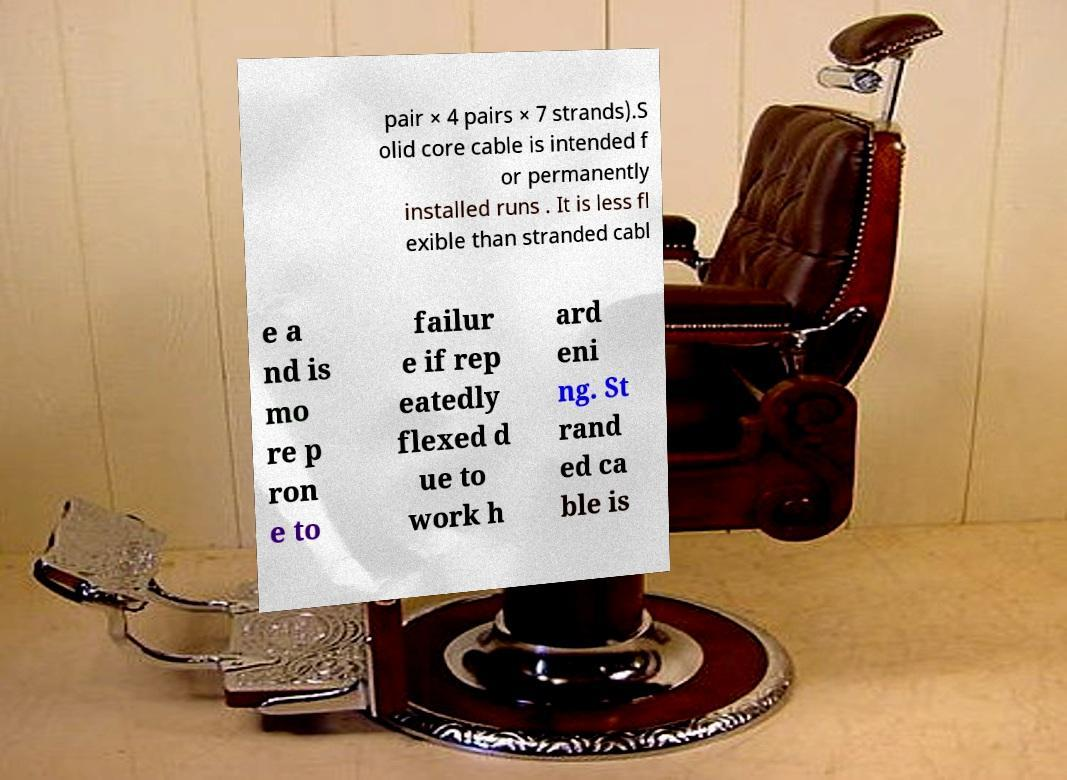What messages or text are displayed in this image? I need them in a readable, typed format. pair × 4 pairs × 7 strands).S olid core cable is intended f or permanently installed runs . It is less fl exible than stranded cabl e a nd is mo re p ron e to failur e if rep eatedly flexed d ue to work h ard eni ng. St rand ed ca ble is 